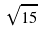<formula> <loc_0><loc_0><loc_500><loc_500>\sqrt { 1 5 }</formula> 